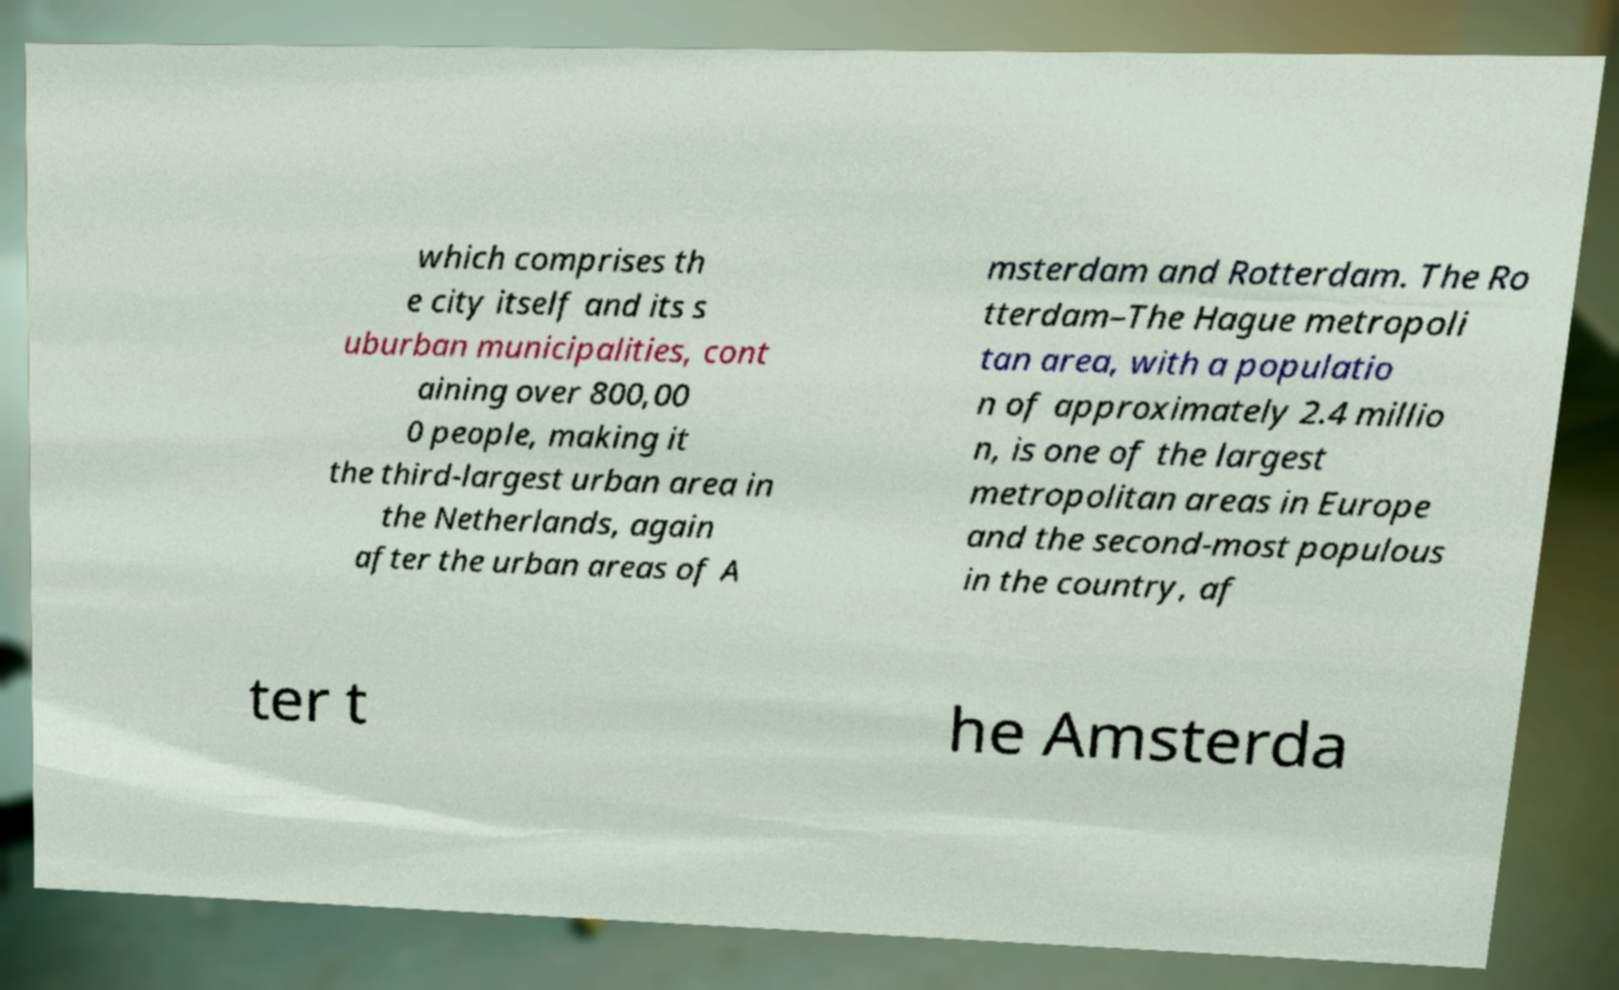What messages or text are displayed in this image? I need them in a readable, typed format. which comprises th e city itself and its s uburban municipalities, cont aining over 800,00 0 people, making it the third-largest urban area in the Netherlands, again after the urban areas of A msterdam and Rotterdam. The Ro tterdam–The Hague metropoli tan area, with a populatio n of approximately 2.4 millio n, is one of the largest metropolitan areas in Europe and the second-most populous in the country, af ter t he Amsterda 